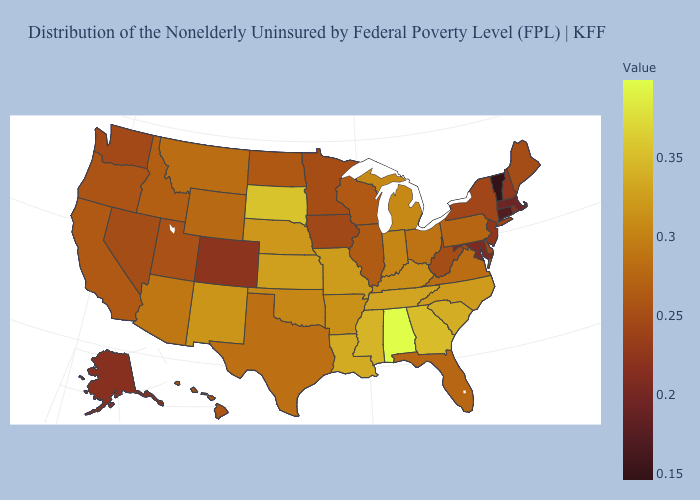Which states have the lowest value in the USA?
Keep it brief. Vermont. Does Vermont have the lowest value in the USA?
Short answer required. Yes. Is the legend a continuous bar?
Short answer required. Yes. Does Montana have the lowest value in the West?
Answer briefly. No. 